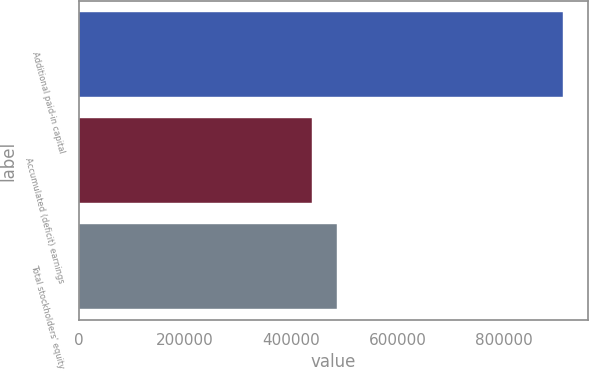Convert chart to OTSL. <chart><loc_0><loc_0><loc_500><loc_500><bar_chart><fcel>Additional paid-in capital<fcel>Accumulated (deficit) earnings<fcel>Total stockholders' equity<nl><fcel>911714<fcel>439435<fcel>486663<nl></chart> 